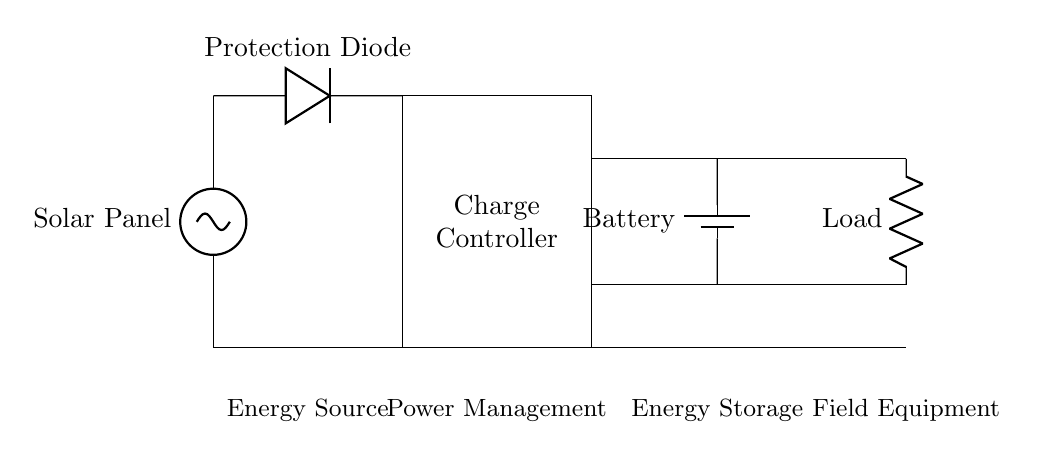What is the energy source in this circuit? The energy source is the solar panel, which converts sunlight into electrical energy needed for the circuit operation.
Answer: Solar panel What component prevents reverse current flow? The component that prevents reverse current flow is the protection diode, which allows current to flow only in one direction.
Answer: Protection diode How many main components are visible in the circuit? The main components visible in the circuit are the solar panel, protection diode, charge controller, battery, and load, totaling five components.
Answer: Five What is the purpose of the charge controller? The charge controller's purpose is to manage the voltage and current flowing from the solar panel to the battery, preventing overcharging and enhancing battery life.
Answer: Manage battery charging What is the storage component in the circuit? The storage component in the circuit is the battery, which stores energy generated by the solar panel for later use by the load.
Answer: Battery What type of load is represented in the circuit? The type of load represented in the circuit is a resistor, which symbolizes the field equipment that consumes the stored energy for operation.
Answer: Resistor 